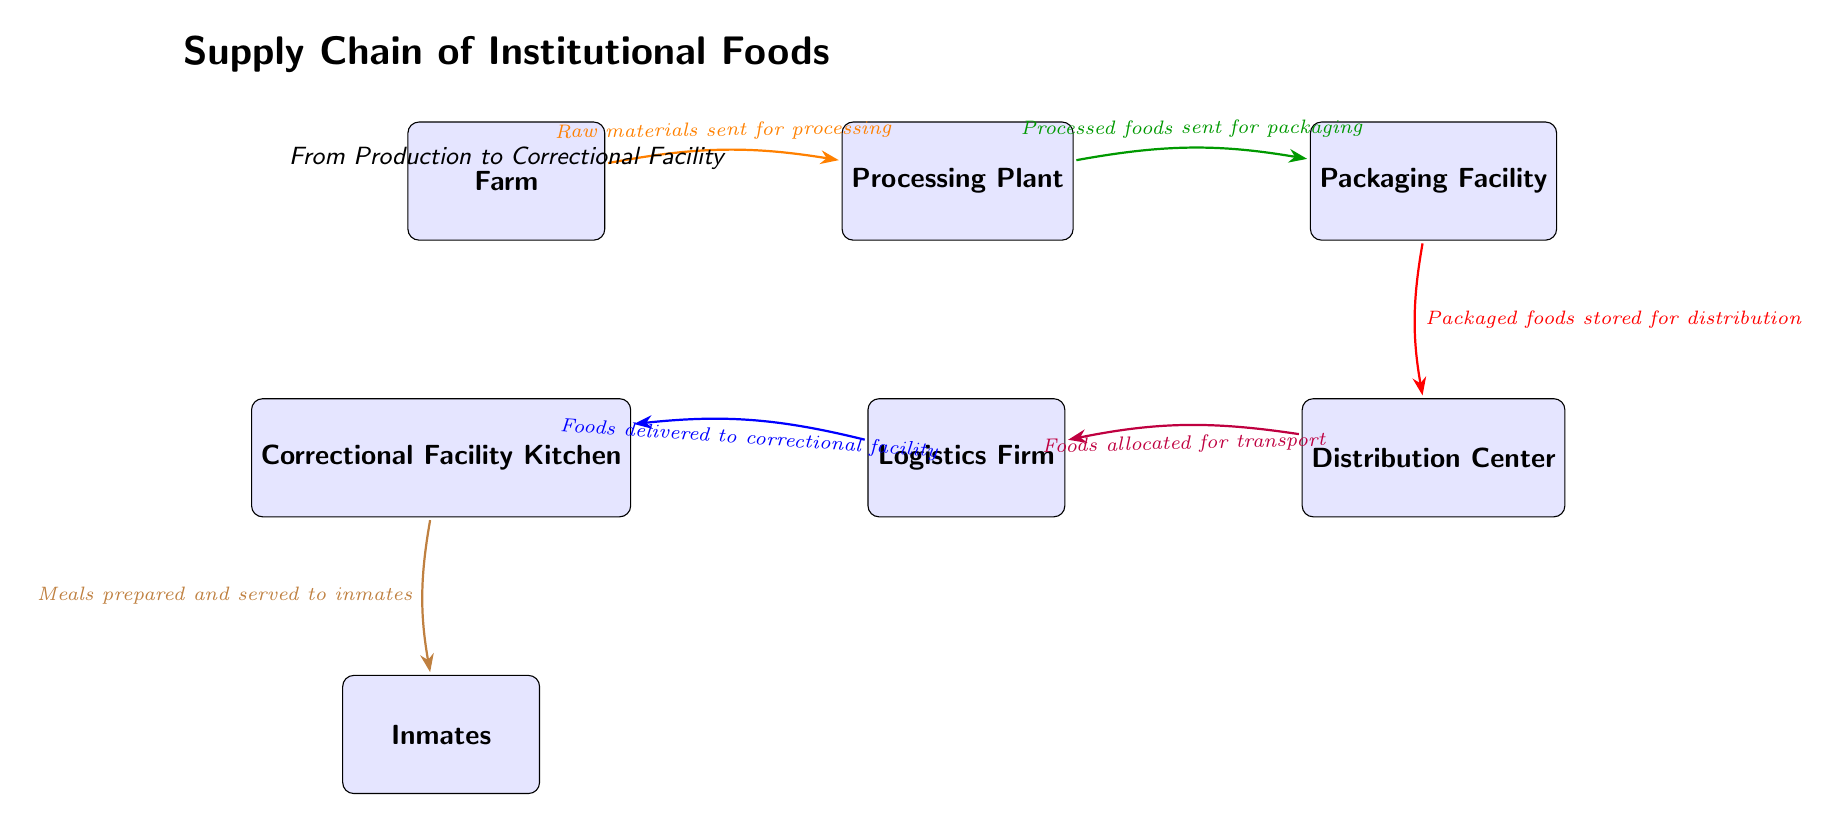What is the first stage in the supply chain? The first node in the diagram is labeled "Farm," indicating that farming is the initial stage of the supply chain for institutional foods.
Answer: Farm How many stages are shown in the supply chain? The diagram features six distinct stages: Farm, Processing Plant, Packaging Facility, Distribution Center, Logistics Firm, and Correctional Facility Kitchen. Counting these nodes gives a total of six stages.
Answer: 6 What happens to the processed foods? According to the diagram, processed foods are sent for packaging after they are finished processing. This is represented by the directed arrow from the Processing Plant to the Packaging Facility.
Answer: Processed foods sent for packaging What entity receives the packaged foods? The Distribution Center is the node that receives the packaged foods, as indicated by the arrow leading into it from the Packaging Facility.
Answer: Distribution Center What is the final outcome in the supply chain? The final outcome in the supply chain occurs when meals prepared in the correctional facility kitchen are served to inmates, as shown by the arrow leading from the kitchen to the inmates.
Answer: Meals prepared and served to inmates Which stage is responsible for logistics? The Logistics Firm is specifically responsible for logistics within the supply chain, as indicated by its position and the arrow directing foods to the Correctional Facility Kitchen.
Answer: Logistics Firm How do foods move from the Packaging Facility to the Distribution Center? Foods move from the Packaging Facility to the Distribution Center via an arrow labeled "Packaged foods stored for distribution," indicating the storage of these foods before distribution.
Answer: Packaged foods stored for distribution What is located directly below the Correctional Facility Kitchen? Directly below the Correctional Facility Kitchen is the node labeled "Inmates," representing the recipients of the prepared meals at the correctional facility.
Answer: Inmates 